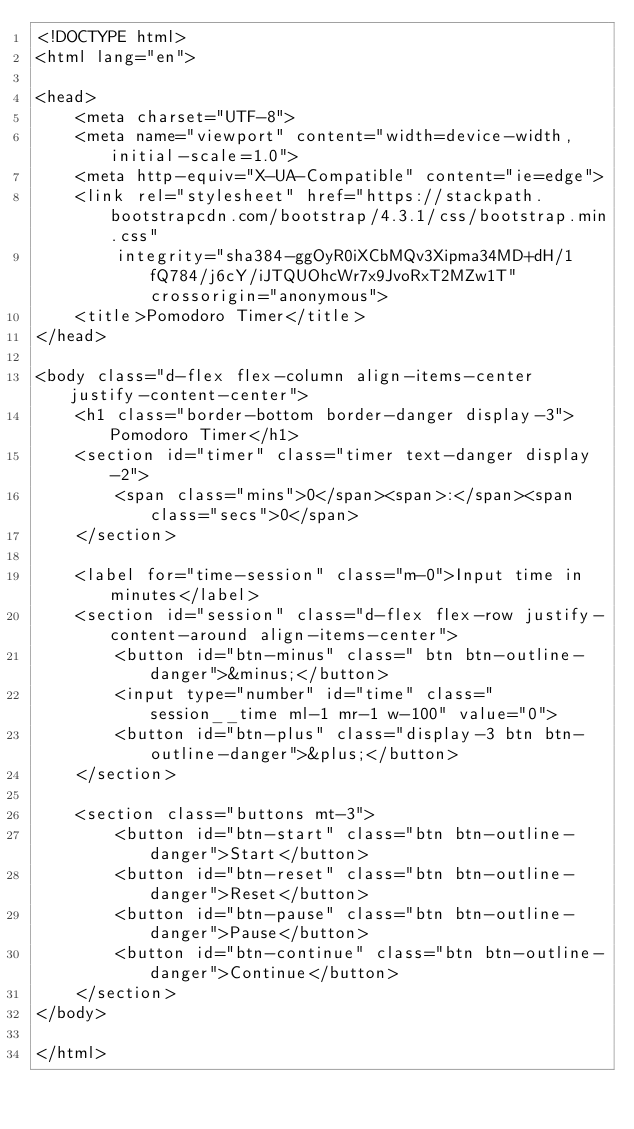Convert code to text. <code><loc_0><loc_0><loc_500><loc_500><_HTML_><!DOCTYPE html>
<html lang="en">

<head>
    <meta charset="UTF-8">
    <meta name="viewport" content="width=device-width, initial-scale=1.0">
    <meta http-equiv="X-UA-Compatible" content="ie=edge">
    <link rel="stylesheet" href="https://stackpath.bootstrapcdn.com/bootstrap/4.3.1/css/bootstrap.min.css"
        integrity="sha384-ggOyR0iXCbMQv3Xipma34MD+dH/1fQ784/j6cY/iJTQUOhcWr7x9JvoRxT2MZw1T" crossorigin="anonymous">
    <title>Pomodoro Timer</title>
</head>

<body class="d-flex flex-column align-items-center justify-content-center">
    <h1 class="border-bottom border-danger display-3">Pomodoro Timer</h1>
    <section id="timer" class="timer text-danger display-2">
        <span class="mins">0</span><span>:</span><span class="secs">0</span>
    </section>

    <label for="time-session" class="m-0">Input time in minutes</label>
    <section id="session" class="d-flex flex-row justify-content-around align-items-center">
        <button id="btn-minus" class=" btn btn-outline-danger">&minus;</button>
        <input type="number" id="time" class="session__time ml-1 mr-1 w-100" value="0">
        <button id="btn-plus" class="display-3 btn btn-outline-danger">&plus;</button>
    </section>

    <section class="buttons mt-3">
        <button id="btn-start" class="btn btn-outline-danger">Start</button>
        <button id="btn-reset" class="btn btn-outline-danger">Reset</button>
        <button id="btn-pause" class="btn btn-outline-danger">Pause</button>
        <button id="btn-continue" class="btn btn-outline-danger">Continue</button>
    </section>
</body>

</html></code> 